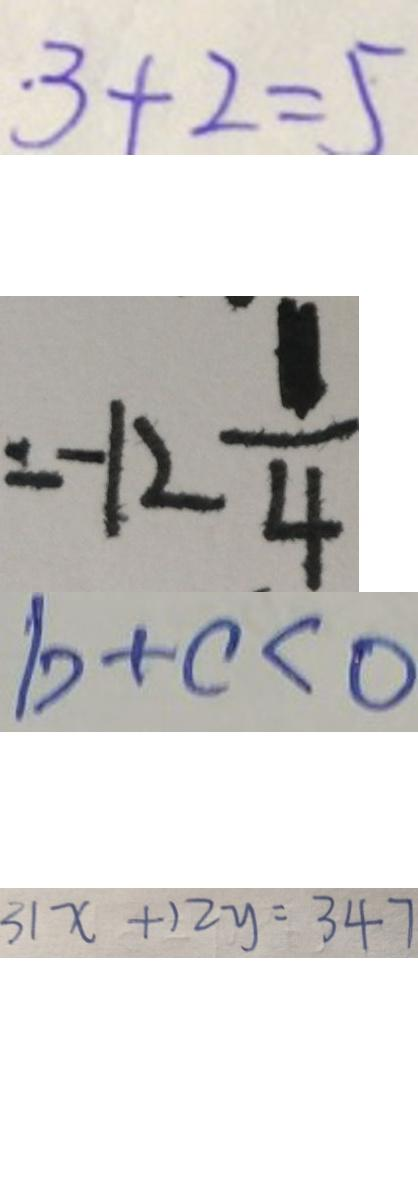Convert formula to latex. <formula><loc_0><loc_0><loc_500><loc_500>3 + 2 = 5 
 = - 1 2 \frac { 1 } { 4 } 
 b + c < 0 
 3 1 x + 1 2 y = 3 4 7</formula> 